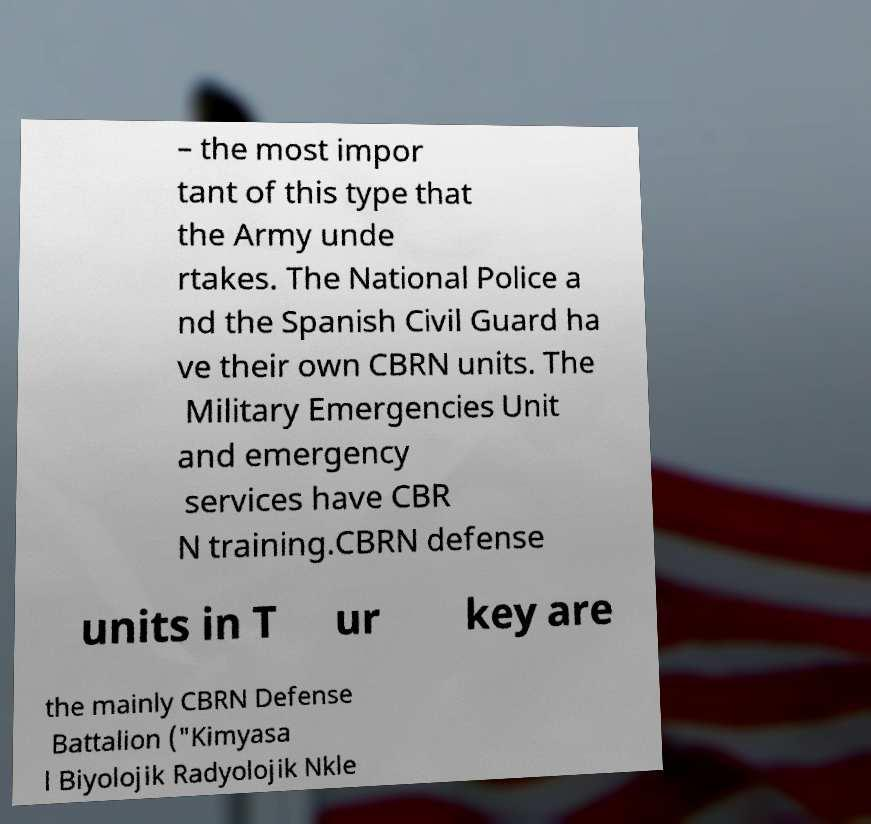What messages or text are displayed in this image? I need them in a readable, typed format. – the most impor tant of this type that the Army unde rtakes. The National Police a nd the Spanish Civil Guard ha ve their own CBRN units. The Military Emergencies Unit and emergency services have CBR N training.CBRN defense units in T ur key are the mainly CBRN Defense Battalion ("Kimyasa l Biyolojik Radyolojik Nkle 